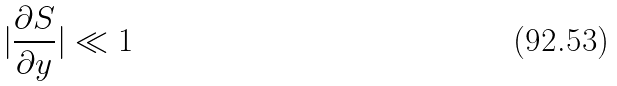<formula> <loc_0><loc_0><loc_500><loc_500>| \frac { \partial S } { \partial y } | \ll 1</formula> 